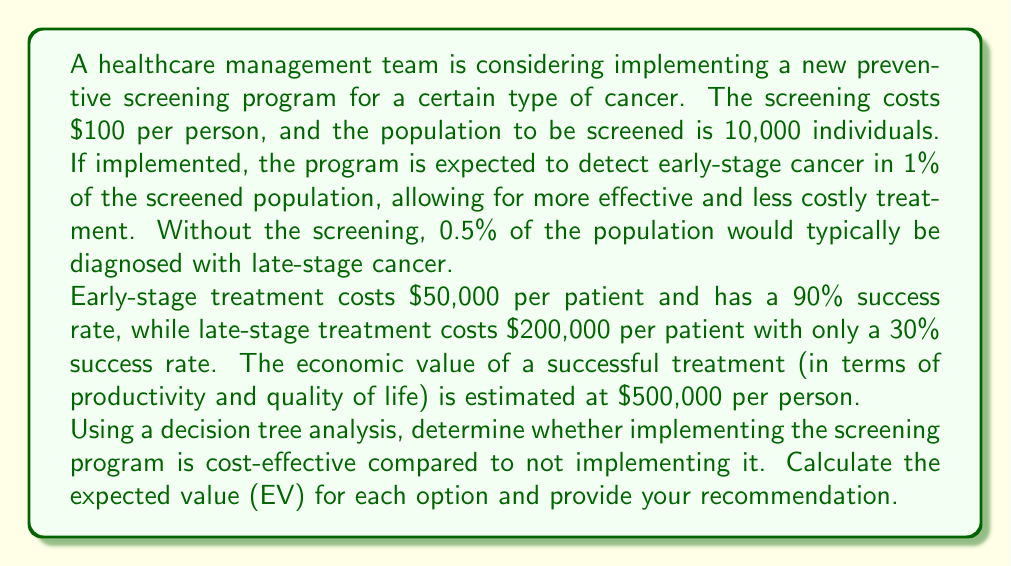Solve this math problem. Let's break this down step-by-step using a decision tree analysis:

1. First, let's calculate the probabilities and costs for each branch of the decision tree.

For the screening program:
- Cost of screening: $100 × 10,000 = $1,000,000
- Number of early-stage cases: 1% of 10,000 = 100
- Number of non-cases: 99% of 10,000 = 9,900

For no screening:
- Number of late-stage cases: 0.5% of 10,000 = 50
- Number of non-cases: 99.5% of 10,000 = 9,950

2. Now, let's calculate the expected value (EV) for each option:

a) Implementing the screening program:

$$ EV_{screening} = P(early) \times [P(success) \times Value - Treatment_{cost}] - Screening_{cost} $$

$$ EV_{screening} = 100 \times [0.9 \times 500,000 - 50,000] - 1,000,000 $$
$$ EV_{screening} = 100 \times [450,000 - 50,000] - 1,000,000 $$
$$ EV_{screening} = 100 \times 400,000 - 1,000,000 $$
$$ EV_{screening} = 40,000,000 - 1,000,000 = 39,000,000 $$

b) Not implementing the screening program:

$$ EV_{no screening} = P(late) \times [P(success) \times Value - Treatment_{cost}] $$

$$ EV_{no screening} = 50 \times [0.3 \times 500,000 - 200,000] $$
$$ EV_{no screening} = 50 \times [150,000 - 200,000] $$
$$ EV_{no screening} = 50 \times (-50,000) = -2,500,000 $$

3. Compare the expected values:

The expected value of implementing the screening program ($39,000,000) is significantly higher than not implementing it (-$2,500,000).

4. Decision tree representation:

[asy]
import geometry;

pair A=(0,0), B=(100,50), C=(100,-50);
pair D=(200,75), E=(200,25), F=(200,-25), G=(200,-75);

draw(A--B--D);
draw(B--E);
draw(A--C--F);
draw(C--G);

label("Implement Screening", (50,25), E);
label("No Screening", (50,-25), E);
label("Early Stage (1%)", (150,62.5), E);
label("No Cancer (99%)", (150,37.5), E);
label("Late Stage (0.5%)", (150,-37.5), E);
label("No Cancer (99.5%)", (150,-62.5), E);

dot(A);
[/asy]
Answer: Based on the decision tree analysis, implementing the screening program is cost-effective. The expected value of implementing the screening program ($39,000,000) is significantly higher than not implementing it (-$2,500,000). Therefore, the recommendation is to implement the preventive screening program. 